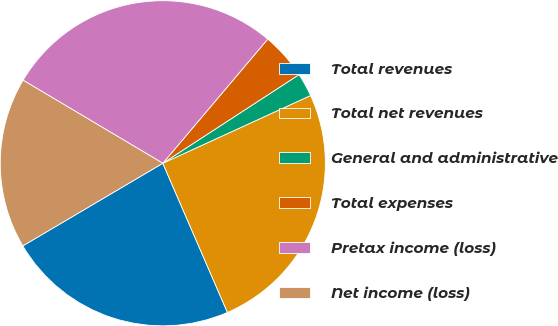<chart> <loc_0><loc_0><loc_500><loc_500><pie_chart><fcel>Total revenues<fcel>Total net revenues<fcel>General and administrative<fcel>Total expenses<fcel>Pretax income (loss)<fcel>Net income (loss)<nl><fcel>23.02%<fcel>25.33%<fcel>2.34%<fcel>4.65%<fcel>27.63%<fcel>17.02%<nl></chart> 